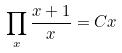<formula> <loc_0><loc_0><loc_500><loc_500>\prod _ { x } \frac { x + 1 } { x } = C x</formula> 